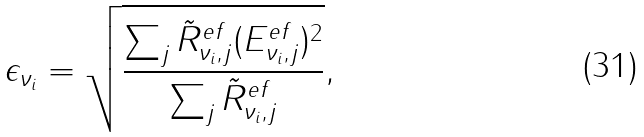Convert formula to latex. <formula><loc_0><loc_0><loc_500><loc_500>\epsilon _ { \nu _ { i } } = \sqrt { \frac { \sum _ { j } \tilde { R } ^ { e f } _ { \nu _ { i } , j } ( E ^ { e f } _ { \nu _ { i } , j } ) ^ { 2 } } { \sum _ { j } \tilde { R } ^ { e f } _ { \nu _ { i } , j } } } ,</formula> 